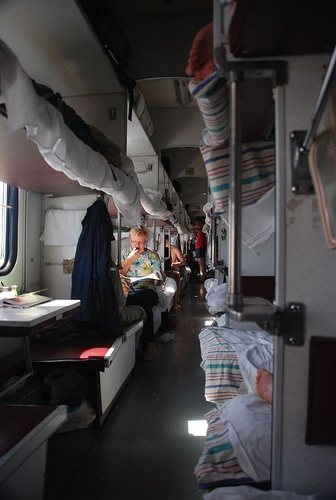Describe the objects in this image and their specific colors. I can see bed in black and gray tones, bed in black and gray tones, bench in black, gray, salmon, and maroon tones, bench in black and gray tones, and bed in black, darkgray, and gray tones in this image. 